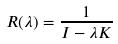Convert formula to latex. <formula><loc_0><loc_0><loc_500><loc_500>R ( \lambda ) = \frac { 1 } { I - \lambda K }</formula> 